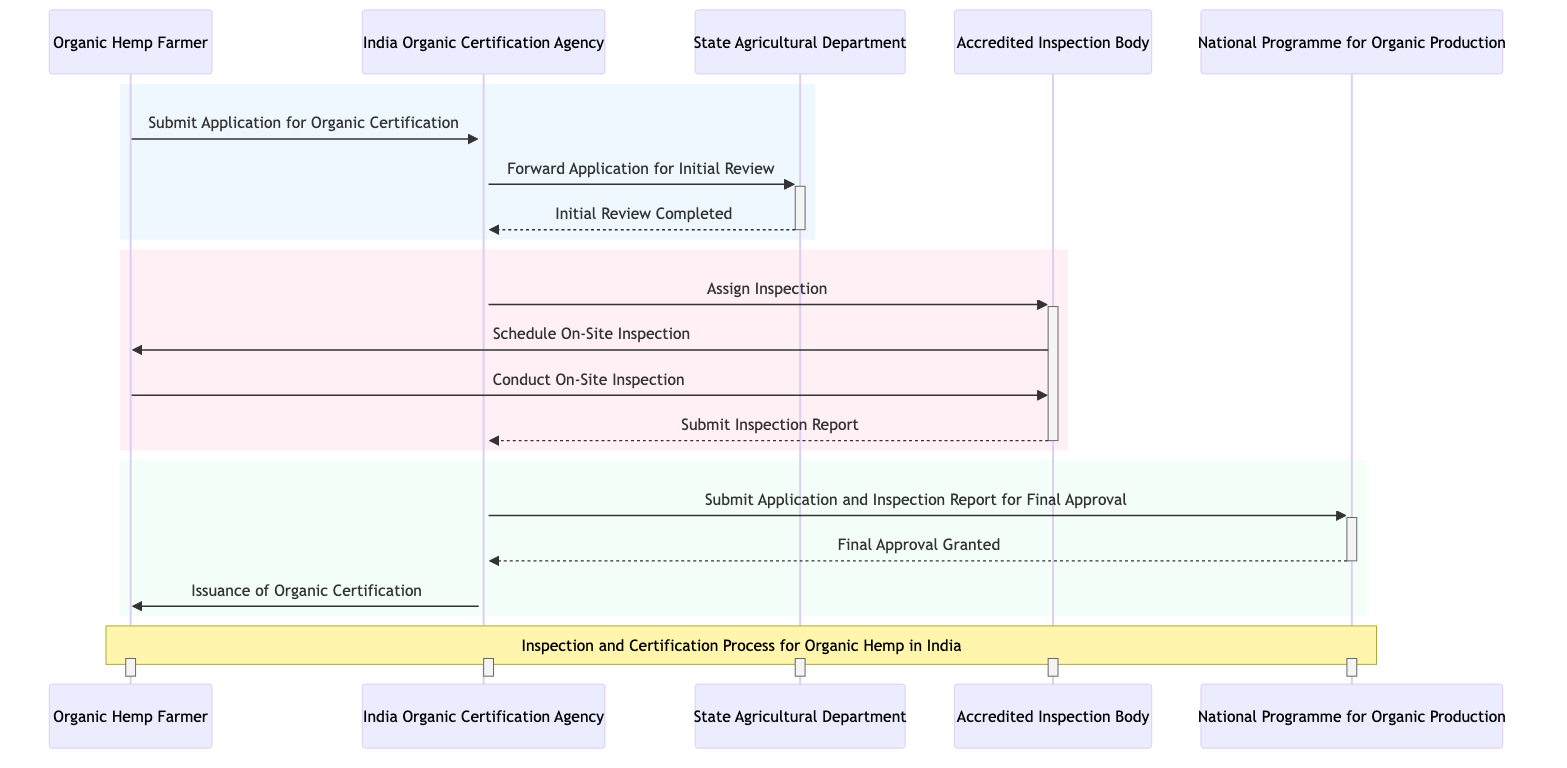What is the first action taken by the Organic Hemp Farmer? The diagram shows that the first action taken by the Organic Hemp Farmer is to submit an application for organic certification. This is represented by the first message in the sequence diagram.
Answer: Submit Application for Organic Certification How many participants are involved in the process? By examining the participant list in the diagram, we can see there are five different participants involved in the inspection and certification process.
Answer: Five What message is sent from the State Agricultural Department to the India Organic Certification Agency? According to the diagram, after the initial review is completed by the State Agricultural Department, the message sent back to the India Organic Certification Agency is "Initial Review Completed". This represents a confirmation of the review's status.
Answer: Initial Review Completed Which participant is responsible for conducting the on-site inspection? The Accredited Inspection Body is responsible for conducting the on-site inspection as indicated by the message "Conduct On-Site Inspection" being sent from the Organic Hemp Farmer to the Accredited Inspection Body.
Answer: Accredited Inspection Body What does the India Organic Certification Agency do after receiving the inspection report? After receiving the inspection report from the Accredited Inspection Body, the India Organic Certification Agency submits the application and inspection report for final approval to the National Programme for Organic Production (NPOP). This is shown as a flow of messages in the diagram.
Answer: Submit Application and Inspection Report for Final Approval How many steps occur between the submission of the application and the issuance of the organic certification? The sequence diagram illustrates several steps: the application submission, initial review completion, assignment of inspection, scheduling and conducting of the inspection, submitting the inspection report, seeking final approval, and finally the issuance of organic certification. Counting these steps gives a total of six distinct actions.
Answer: Six What is the last action taken in the sequence diagram? The last action taken in the sequence diagram is the issuance of organic certification to the Organic Hemp Farmer by the India Organic Certification Agency. This is the concluding message in the process flow.
Answer: Issuance of Organic Certification Which agency is responsible for granting the final approval? The final approval is granted by the National Programme for Organic Production (NPOP), as indicated by the message "Final Approval Granted" sent back to the India Organic Certification Agency.
Answer: National Programme for Organic Production What type of relationship exists between the India Organic Certification Agency and the Accredited Inspection Body? The diagram shows that the India Organic Certification Agency assigns inspections to the Accredited Inspection Body, indicating a directional relationship where one agency relies on the other for inspection tasks.
Answer: Assign Inspection 